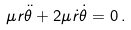<formula> <loc_0><loc_0><loc_500><loc_500>\mu r \ddot { \theta } + 2 \mu \dot { r } \dot { \theta } = 0 \, .</formula> 